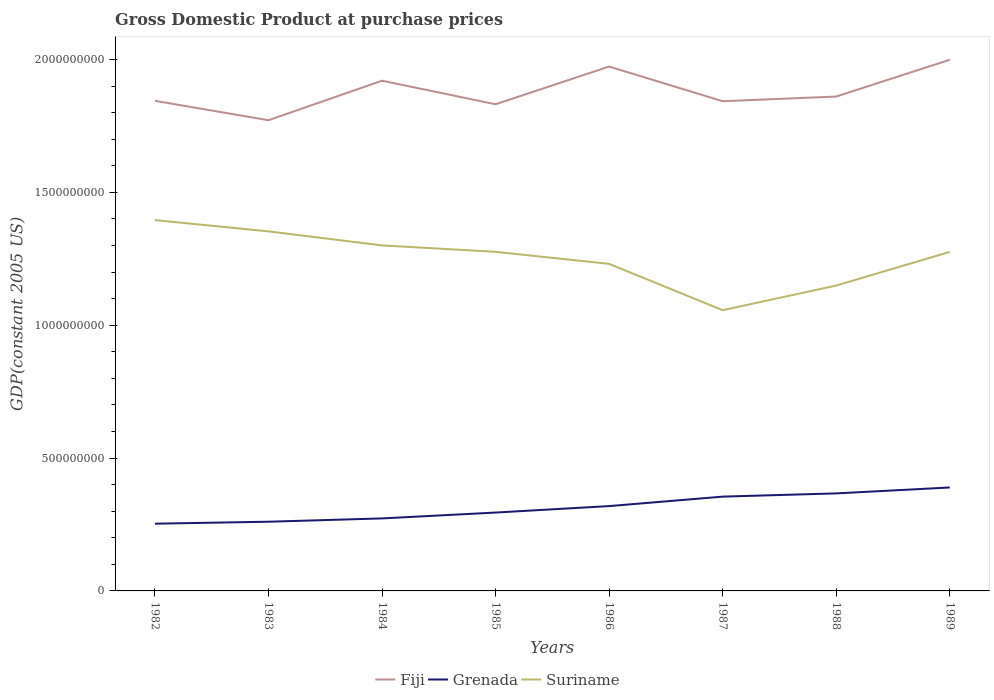How many different coloured lines are there?
Make the answer very short. 3. Does the line corresponding to Suriname intersect with the line corresponding to Fiji?
Make the answer very short. No. Across all years, what is the maximum GDP at purchase prices in Grenada?
Keep it short and to the point. 2.53e+08. What is the total GDP at purchase prices in Grenada in the graph?
Make the answer very short. -9.44e+07. What is the difference between the highest and the second highest GDP at purchase prices in Grenada?
Your answer should be very brief. 1.36e+08. Is the GDP at purchase prices in Suriname strictly greater than the GDP at purchase prices in Grenada over the years?
Your response must be concise. No. How many years are there in the graph?
Your response must be concise. 8. Does the graph contain any zero values?
Provide a short and direct response. No. Does the graph contain grids?
Keep it short and to the point. No. Where does the legend appear in the graph?
Provide a short and direct response. Bottom center. How many legend labels are there?
Your response must be concise. 3. How are the legend labels stacked?
Offer a very short reply. Horizontal. What is the title of the graph?
Your answer should be very brief. Gross Domestic Product at purchase prices. Does "Cameroon" appear as one of the legend labels in the graph?
Provide a succinct answer. No. What is the label or title of the Y-axis?
Make the answer very short. GDP(constant 2005 US). What is the GDP(constant 2005 US) of Fiji in 1982?
Keep it short and to the point. 1.84e+09. What is the GDP(constant 2005 US) of Grenada in 1982?
Your answer should be very brief. 2.53e+08. What is the GDP(constant 2005 US) of Suriname in 1982?
Ensure brevity in your answer.  1.40e+09. What is the GDP(constant 2005 US) in Fiji in 1983?
Keep it short and to the point. 1.77e+09. What is the GDP(constant 2005 US) in Grenada in 1983?
Provide a succinct answer. 2.60e+08. What is the GDP(constant 2005 US) of Suriname in 1983?
Give a very brief answer. 1.35e+09. What is the GDP(constant 2005 US) in Fiji in 1984?
Give a very brief answer. 1.92e+09. What is the GDP(constant 2005 US) in Grenada in 1984?
Your response must be concise. 2.73e+08. What is the GDP(constant 2005 US) in Suriname in 1984?
Your response must be concise. 1.30e+09. What is the GDP(constant 2005 US) of Fiji in 1985?
Offer a terse response. 1.83e+09. What is the GDP(constant 2005 US) of Grenada in 1985?
Ensure brevity in your answer.  2.95e+08. What is the GDP(constant 2005 US) of Suriname in 1985?
Your answer should be very brief. 1.28e+09. What is the GDP(constant 2005 US) of Fiji in 1986?
Offer a terse response. 1.97e+09. What is the GDP(constant 2005 US) of Grenada in 1986?
Offer a terse response. 3.19e+08. What is the GDP(constant 2005 US) of Suriname in 1986?
Your answer should be compact. 1.23e+09. What is the GDP(constant 2005 US) of Fiji in 1987?
Your response must be concise. 1.84e+09. What is the GDP(constant 2005 US) of Grenada in 1987?
Your answer should be very brief. 3.55e+08. What is the GDP(constant 2005 US) in Suriname in 1987?
Make the answer very short. 1.06e+09. What is the GDP(constant 2005 US) of Fiji in 1988?
Give a very brief answer. 1.86e+09. What is the GDP(constant 2005 US) of Grenada in 1988?
Keep it short and to the point. 3.67e+08. What is the GDP(constant 2005 US) in Suriname in 1988?
Make the answer very short. 1.15e+09. What is the GDP(constant 2005 US) in Fiji in 1989?
Your answer should be very brief. 2.00e+09. What is the GDP(constant 2005 US) of Grenada in 1989?
Give a very brief answer. 3.89e+08. What is the GDP(constant 2005 US) in Suriname in 1989?
Your response must be concise. 1.28e+09. Across all years, what is the maximum GDP(constant 2005 US) in Fiji?
Your answer should be very brief. 2.00e+09. Across all years, what is the maximum GDP(constant 2005 US) in Grenada?
Provide a short and direct response. 3.89e+08. Across all years, what is the maximum GDP(constant 2005 US) of Suriname?
Your answer should be very brief. 1.40e+09. Across all years, what is the minimum GDP(constant 2005 US) of Fiji?
Offer a terse response. 1.77e+09. Across all years, what is the minimum GDP(constant 2005 US) in Grenada?
Your answer should be compact. 2.53e+08. Across all years, what is the minimum GDP(constant 2005 US) of Suriname?
Provide a short and direct response. 1.06e+09. What is the total GDP(constant 2005 US) in Fiji in the graph?
Give a very brief answer. 1.50e+1. What is the total GDP(constant 2005 US) of Grenada in the graph?
Keep it short and to the point. 2.51e+09. What is the total GDP(constant 2005 US) of Suriname in the graph?
Your answer should be very brief. 1.00e+1. What is the difference between the GDP(constant 2005 US) in Fiji in 1982 and that in 1983?
Keep it short and to the point. 7.30e+07. What is the difference between the GDP(constant 2005 US) of Grenada in 1982 and that in 1983?
Give a very brief answer. -7.40e+06. What is the difference between the GDP(constant 2005 US) of Suriname in 1982 and that in 1983?
Your answer should be very brief. 4.25e+07. What is the difference between the GDP(constant 2005 US) of Fiji in 1982 and that in 1984?
Give a very brief answer. -7.56e+07. What is the difference between the GDP(constant 2005 US) of Grenada in 1982 and that in 1984?
Your answer should be very brief. -1.99e+07. What is the difference between the GDP(constant 2005 US) of Suriname in 1982 and that in 1984?
Your answer should be very brief. 9.53e+07. What is the difference between the GDP(constant 2005 US) in Fiji in 1982 and that in 1985?
Your response must be concise. 1.29e+07. What is the difference between the GDP(constant 2005 US) in Grenada in 1982 and that in 1985?
Keep it short and to the point. -4.19e+07. What is the difference between the GDP(constant 2005 US) of Suriname in 1982 and that in 1985?
Offer a very short reply. 1.19e+08. What is the difference between the GDP(constant 2005 US) in Fiji in 1982 and that in 1986?
Offer a very short reply. -1.29e+08. What is the difference between the GDP(constant 2005 US) of Grenada in 1982 and that in 1986?
Your answer should be very brief. -6.62e+07. What is the difference between the GDP(constant 2005 US) in Suriname in 1982 and that in 1986?
Provide a succinct answer. 1.65e+08. What is the difference between the GDP(constant 2005 US) in Fiji in 1982 and that in 1987?
Make the answer very short. 1.55e+06. What is the difference between the GDP(constant 2005 US) in Grenada in 1982 and that in 1987?
Offer a very short reply. -1.02e+08. What is the difference between the GDP(constant 2005 US) in Suriname in 1982 and that in 1987?
Provide a succinct answer. 3.39e+08. What is the difference between the GDP(constant 2005 US) of Fiji in 1982 and that in 1988?
Ensure brevity in your answer.  -1.61e+07. What is the difference between the GDP(constant 2005 US) of Grenada in 1982 and that in 1988?
Your answer should be very brief. -1.14e+08. What is the difference between the GDP(constant 2005 US) in Suriname in 1982 and that in 1988?
Provide a succinct answer. 2.46e+08. What is the difference between the GDP(constant 2005 US) of Fiji in 1982 and that in 1989?
Provide a succinct answer. -1.54e+08. What is the difference between the GDP(constant 2005 US) in Grenada in 1982 and that in 1989?
Make the answer very short. -1.36e+08. What is the difference between the GDP(constant 2005 US) in Suriname in 1982 and that in 1989?
Offer a very short reply. 1.20e+08. What is the difference between the GDP(constant 2005 US) in Fiji in 1983 and that in 1984?
Your response must be concise. -1.49e+08. What is the difference between the GDP(constant 2005 US) of Grenada in 1983 and that in 1984?
Your response must be concise. -1.25e+07. What is the difference between the GDP(constant 2005 US) in Suriname in 1983 and that in 1984?
Provide a short and direct response. 5.28e+07. What is the difference between the GDP(constant 2005 US) of Fiji in 1983 and that in 1985?
Your answer should be very brief. -6.01e+07. What is the difference between the GDP(constant 2005 US) in Grenada in 1983 and that in 1985?
Keep it short and to the point. -3.45e+07. What is the difference between the GDP(constant 2005 US) of Suriname in 1983 and that in 1985?
Your response must be concise. 7.70e+07. What is the difference between the GDP(constant 2005 US) in Fiji in 1983 and that in 1986?
Provide a succinct answer. -2.02e+08. What is the difference between the GDP(constant 2005 US) of Grenada in 1983 and that in 1986?
Offer a very short reply. -5.88e+07. What is the difference between the GDP(constant 2005 US) of Suriname in 1983 and that in 1986?
Ensure brevity in your answer.  1.22e+08. What is the difference between the GDP(constant 2005 US) in Fiji in 1983 and that in 1987?
Offer a terse response. -7.15e+07. What is the difference between the GDP(constant 2005 US) in Grenada in 1983 and that in 1987?
Provide a short and direct response. -9.44e+07. What is the difference between the GDP(constant 2005 US) of Suriname in 1983 and that in 1987?
Give a very brief answer. 2.97e+08. What is the difference between the GDP(constant 2005 US) in Fiji in 1983 and that in 1988?
Your answer should be compact. -8.91e+07. What is the difference between the GDP(constant 2005 US) in Grenada in 1983 and that in 1988?
Your answer should be compact. -1.07e+08. What is the difference between the GDP(constant 2005 US) of Suriname in 1983 and that in 1988?
Ensure brevity in your answer.  2.04e+08. What is the difference between the GDP(constant 2005 US) of Fiji in 1983 and that in 1989?
Your answer should be compact. -2.27e+08. What is the difference between the GDP(constant 2005 US) in Grenada in 1983 and that in 1989?
Give a very brief answer. -1.29e+08. What is the difference between the GDP(constant 2005 US) in Suriname in 1983 and that in 1989?
Make the answer very short. 7.72e+07. What is the difference between the GDP(constant 2005 US) of Fiji in 1984 and that in 1985?
Your answer should be compact. 8.86e+07. What is the difference between the GDP(constant 2005 US) of Grenada in 1984 and that in 1985?
Offer a terse response. -2.20e+07. What is the difference between the GDP(constant 2005 US) of Suriname in 1984 and that in 1985?
Your answer should be very brief. 2.42e+07. What is the difference between the GDP(constant 2005 US) of Fiji in 1984 and that in 1986?
Your response must be concise. -5.34e+07. What is the difference between the GDP(constant 2005 US) in Grenada in 1984 and that in 1986?
Your answer should be very brief. -4.64e+07. What is the difference between the GDP(constant 2005 US) in Suriname in 1984 and that in 1986?
Provide a succinct answer. 6.94e+07. What is the difference between the GDP(constant 2005 US) in Fiji in 1984 and that in 1987?
Ensure brevity in your answer.  7.72e+07. What is the difference between the GDP(constant 2005 US) in Grenada in 1984 and that in 1987?
Offer a terse response. -8.20e+07. What is the difference between the GDP(constant 2005 US) of Suriname in 1984 and that in 1987?
Your answer should be compact. 2.44e+08. What is the difference between the GDP(constant 2005 US) of Fiji in 1984 and that in 1988?
Your answer should be compact. 5.96e+07. What is the difference between the GDP(constant 2005 US) in Grenada in 1984 and that in 1988?
Provide a succinct answer. -9.41e+07. What is the difference between the GDP(constant 2005 US) in Suriname in 1984 and that in 1988?
Keep it short and to the point. 1.51e+08. What is the difference between the GDP(constant 2005 US) of Fiji in 1984 and that in 1989?
Give a very brief answer. -7.88e+07. What is the difference between the GDP(constant 2005 US) in Grenada in 1984 and that in 1989?
Ensure brevity in your answer.  -1.16e+08. What is the difference between the GDP(constant 2005 US) in Suriname in 1984 and that in 1989?
Ensure brevity in your answer.  2.44e+07. What is the difference between the GDP(constant 2005 US) in Fiji in 1985 and that in 1986?
Your answer should be very brief. -1.42e+08. What is the difference between the GDP(constant 2005 US) in Grenada in 1985 and that in 1986?
Keep it short and to the point. -2.43e+07. What is the difference between the GDP(constant 2005 US) of Suriname in 1985 and that in 1986?
Offer a very short reply. 4.52e+07. What is the difference between the GDP(constant 2005 US) of Fiji in 1985 and that in 1987?
Keep it short and to the point. -1.14e+07. What is the difference between the GDP(constant 2005 US) in Grenada in 1985 and that in 1987?
Offer a terse response. -5.99e+07. What is the difference between the GDP(constant 2005 US) in Suriname in 1985 and that in 1987?
Your answer should be compact. 2.20e+08. What is the difference between the GDP(constant 2005 US) in Fiji in 1985 and that in 1988?
Make the answer very short. -2.90e+07. What is the difference between the GDP(constant 2005 US) in Grenada in 1985 and that in 1988?
Provide a short and direct response. -7.21e+07. What is the difference between the GDP(constant 2005 US) in Suriname in 1985 and that in 1988?
Your response must be concise. 1.27e+08. What is the difference between the GDP(constant 2005 US) in Fiji in 1985 and that in 1989?
Ensure brevity in your answer.  -1.67e+08. What is the difference between the GDP(constant 2005 US) of Grenada in 1985 and that in 1989?
Provide a succinct answer. -9.44e+07. What is the difference between the GDP(constant 2005 US) of Suriname in 1985 and that in 1989?
Ensure brevity in your answer.  2.67e+05. What is the difference between the GDP(constant 2005 US) in Fiji in 1986 and that in 1987?
Offer a terse response. 1.31e+08. What is the difference between the GDP(constant 2005 US) in Grenada in 1986 and that in 1987?
Your answer should be compact. -3.56e+07. What is the difference between the GDP(constant 2005 US) of Suriname in 1986 and that in 1987?
Offer a very short reply. 1.74e+08. What is the difference between the GDP(constant 2005 US) of Fiji in 1986 and that in 1988?
Your answer should be very brief. 1.13e+08. What is the difference between the GDP(constant 2005 US) in Grenada in 1986 and that in 1988?
Your answer should be compact. -4.78e+07. What is the difference between the GDP(constant 2005 US) in Suriname in 1986 and that in 1988?
Make the answer very short. 8.16e+07. What is the difference between the GDP(constant 2005 US) of Fiji in 1986 and that in 1989?
Offer a terse response. -2.55e+07. What is the difference between the GDP(constant 2005 US) in Grenada in 1986 and that in 1989?
Give a very brief answer. -7.00e+07. What is the difference between the GDP(constant 2005 US) of Suriname in 1986 and that in 1989?
Your answer should be very brief. -4.50e+07. What is the difference between the GDP(constant 2005 US) in Fiji in 1987 and that in 1988?
Make the answer very short. -1.76e+07. What is the difference between the GDP(constant 2005 US) in Grenada in 1987 and that in 1988?
Offer a terse response. -1.22e+07. What is the difference between the GDP(constant 2005 US) in Suriname in 1987 and that in 1988?
Your answer should be very brief. -9.27e+07. What is the difference between the GDP(constant 2005 US) of Fiji in 1987 and that in 1989?
Offer a very short reply. -1.56e+08. What is the difference between the GDP(constant 2005 US) of Grenada in 1987 and that in 1989?
Your answer should be very brief. -3.44e+07. What is the difference between the GDP(constant 2005 US) in Suriname in 1987 and that in 1989?
Give a very brief answer. -2.19e+08. What is the difference between the GDP(constant 2005 US) of Fiji in 1988 and that in 1989?
Ensure brevity in your answer.  -1.38e+08. What is the difference between the GDP(constant 2005 US) of Grenada in 1988 and that in 1989?
Provide a short and direct response. -2.23e+07. What is the difference between the GDP(constant 2005 US) in Suriname in 1988 and that in 1989?
Make the answer very short. -1.27e+08. What is the difference between the GDP(constant 2005 US) of Fiji in 1982 and the GDP(constant 2005 US) of Grenada in 1983?
Offer a terse response. 1.58e+09. What is the difference between the GDP(constant 2005 US) in Fiji in 1982 and the GDP(constant 2005 US) in Suriname in 1983?
Your answer should be very brief. 4.91e+08. What is the difference between the GDP(constant 2005 US) in Grenada in 1982 and the GDP(constant 2005 US) in Suriname in 1983?
Ensure brevity in your answer.  -1.10e+09. What is the difference between the GDP(constant 2005 US) of Fiji in 1982 and the GDP(constant 2005 US) of Grenada in 1984?
Offer a terse response. 1.57e+09. What is the difference between the GDP(constant 2005 US) of Fiji in 1982 and the GDP(constant 2005 US) of Suriname in 1984?
Your answer should be very brief. 5.44e+08. What is the difference between the GDP(constant 2005 US) of Grenada in 1982 and the GDP(constant 2005 US) of Suriname in 1984?
Offer a very short reply. -1.05e+09. What is the difference between the GDP(constant 2005 US) of Fiji in 1982 and the GDP(constant 2005 US) of Grenada in 1985?
Offer a very short reply. 1.55e+09. What is the difference between the GDP(constant 2005 US) in Fiji in 1982 and the GDP(constant 2005 US) in Suriname in 1985?
Offer a terse response. 5.68e+08. What is the difference between the GDP(constant 2005 US) in Grenada in 1982 and the GDP(constant 2005 US) in Suriname in 1985?
Your answer should be very brief. -1.02e+09. What is the difference between the GDP(constant 2005 US) in Fiji in 1982 and the GDP(constant 2005 US) in Grenada in 1986?
Your answer should be very brief. 1.53e+09. What is the difference between the GDP(constant 2005 US) of Fiji in 1982 and the GDP(constant 2005 US) of Suriname in 1986?
Provide a succinct answer. 6.14e+08. What is the difference between the GDP(constant 2005 US) of Grenada in 1982 and the GDP(constant 2005 US) of Suriname in 1986?
Offer a very short reply. -9.78e+08. What is the difference between the GDP(constant 2005 US) in Fiji in 1982 and the GDP(constant 2005 US) in Grenada in 1987?
Your answer should be compact. 1.49e+09. What is the difference between the GDP(constant 2005 US) in Fiji in 1982 and the GDP(constant 2005 US) in Suriname in 1987?
Offer a terse response. 7.88e+08. What is the difference between the GDP(constant 2005 US) of Grenada in 1982 and the GDP(constant 2005 US) of Suriname in 1987?
Provide a short and direct response. -8.03e+08. What is the difference between the GDP(constant 2005 US) of Fiji in 1982 and the GDP(constant 2005 US) of Grenada in 1988?
Your answer should be compact. 1.48e+09. What is the difference between the GDP(constant 2005 US) in Fiji in 1982 and the GDP(constant 2005 US) in Suriname in 1988?
Ensure brevity in your answer.  6.95e+08. What is the difference between the GDP(constant 2005 US) in Grenada in 1982 and the GDP(constant 2005 US) in Suriname in 1988?
Offer a terse response. -8.96e+08. What is the difference between the GDP(constant 2005 US) of Fiji in 1982 and the GDP(constant 2005 US) of Grenada in 1989?
Keep it short and to the point. 1.46e+09. What is the difference between the GDP(constant 2005 US) in Fiji in 1982 and the GDP(constant 2005 US) in Suriname in 1989?
Your response must be concise. 5.69e+08. What is the difference between the GDP(constant 2005 US) in Grenada in 1982 and the GDP(constant 2005 US) in Suriname in 1989?
Give a very brief answer. -1.02e+09. What is the difference between the GDP(constant 2005 US) in Fiji in 1983 and the GDP(constant 2005 US) in Grenada in 1984?
Ensure brevity in your answer.  1.50e+09. What is the difference between the GDP(constant 2005 US) in Fiji in 1983 and the GDP(constant 2005 US) in Suriname in 1984?
Give a very brief answer. 4.71e+08. What is the difference between the GDP(constant 2005 US) in Grenada in 1983 and the GDP(constant 2005 US) in Suriname in 1984?
Provide a succinct answer. -1.04e+09. What is the difference between the GDP(constant 2005 US) of Fiji in 1983 and the GDP(constant 2005 US) of Grenada in 1985?
Give a very brief answer. 1.48e+09. What is the difference between the GDP(constant 2005 US) of Fiji in 1983 and the GDP(constant 2005 US) of Suriname in 1985?
Make the answer very short. 4.95e+08. What is the difference between the GDP(constant 2005 US) of Grenada in 1983 and the GDP(constant 2005 US) of Suriname in 1985?
Your answer should be very brief. -1.02e+09. What is the difference between the GDP(constant 2005 US) in Fiji in 1983 and the GDP(constant 2005 US) in Grenada in 1986?
Your answer should be very brief. 1.45e+09. What is the difference between the GDP(constant 2005 US) of Fiji in 1983 and the GDP(constant 2005 US) of Suriname in 1986?
Offer a very short reply. 5.40e+08. What is the difference between the GDP(constant 2005 US) of Grenada in 1983 and the GDP(constant 2005 US) of Suriname in 1986?
Offer a very short reply. -9.70e+08. What is the difference between the GDP(constant 2005 US) of Fiji in 1983 and the GDP(constant 2005 US) of Grenada in 1987?
Offer a very short reply. 1.42e+09. What is the difference between the GDP(constant 2005 US) of Fiji in 1983 and the GDP(constant 2005 US) of Suriname in 1987?
Ensure brevity in your answer.  7.15e+08. What is the difference between the GDP(constant 2005 US) of Grenada in 1983 and the GDP(constant 2005 US) of Suriname in 1987?
Offer a terse response. -7.96e+08. What is the difference between the GDP(constant 2005 US) in Fiji in 1983 and the GDP(constant 2005 US) in Grenada in 1988?
Provide a succinct answer. 1.40e+09. What is the difference between the GDP(constant 2005 US) in Fiji in 1983 and the GDP(constant 2005 US) in Suriname in 1988?
Provide a succinct answer. 6.22e+08. What is the difference between the GDP(constant 2005 US) of Grenada in 1983 and the GDP(constant 2005 US) of Suriname in 1988?
Your response must be concise. -8.89e+08. What is the difference between the GDP(constant 2005 US) of Fiji in 1983 and the GDP(constant 2005 US) of Grenada in 1989?
Give a very brief answer. 1.38e+09. What is the difference between the GDP(constant 2005 US) of Fiji in 1983 and the GDP(constant 2005 US) of Suriname in 1989?
Give a very brief answer. 4.96e+08. What is the difference between the GDP(constant 2005 US) in Grenada in 1983 and the GDP(constant 2005 US) in Suriname in 1989?
Give a very brief answer. -1.02e+09. What is the difference between the GDP(constant 2005 US) in Fiji in 1984 and the GDP(constant 2005 US) in Grenada in 1985?
Provide a short and direct response. 1.62e+09. What is the difference between the GDP(constant 2005 US) in Fiji in 1984 and the GDP(constant 2005 US) in Suriname in 1985?
Provide a succinct answer. 6.44e+08. What is the difference between the GDP(constant 2005 US) in Grenada in 1984 and the GDP(constant 2005 US) in Suriname in 1985?
Provide a short and direct response. -1.00e+09. What is the difference between the GDP(constant 2005 US) of Fiji in 1984 and the GDP(constant 2005 US) of Grenada in 1986?
Provide a short and direct response. 1.60e+09. What is the difference between the GDP(constant 2005 US) in Fiji in 1984 and the GDP(constant 2005 US) in Suriname in 1986?
Offer a very short reply. 6.89e+08. What is the difference between the GDP(constant 2005 US) of Grenada in 1984 and the GDP(constant 2005 US) of Suriname in 1986?
Make the answer very short. -9.58e+08. What is the difference between the GDP(constant 2005 US) of Fiji in 1984 and the GDP(constant 2005 US) of Grenada in 1987?
Offer a very short reply. 1.57e+09. What is the difference between the GDP(constant 2005 US) in Fiji in 1984 and the GDP(constant 2005 US) in Suriname in 1987?
Keep it short and to the point. 8.63e+08. What is the difference between the GDP(constant 2005 US) of Grenada in 1984 and the GDP(constant 2005 US) of Suriname in 1987?
Make the answer very short. -7.84e+08. What is the difference between the GDP(constant 2005 US) of Fiji in 1984 and the GDP(constant 2005 US) of Grenada in 1988?
Offer a very short reply. 1.55e+09. What is the difference between the GDP(constant 2005 US) in Fiji in 1984 and the GDP(constant 2005 US) in Suriname in 1988?
Ensure brevity in your answer.  7.71e+08. What is the difference between the GDP(constant 2005 US) in Grenada in 1984 and the GDP(constant 2005 US) in Suriname in 1988?
Your answer should be very brief. -8.76e+08. What is the difference between the GDP(constant 2005 US) of Fiji in 1984 and the GDP(constant 2005 US) of Grenada in 1989?
Your answer should be compact. 1.53e+09. What is the difference between the GDP(constant 2005 US) in Fiji in 1984 and the GDP(constant 2005 US) in Suriname in 1989?
Make the answer very short. 6.44e+08. What is the difference between the GDP(constant 2005 US) of Grenada in 1984 and the GDP(constant 2005 US) of Suriname in 1989?
Your answer should be very brief. -1.00e+09. What is the difference between the GDP(constant 2005 US) of Fiji in 1985 and the GDP(constant 2005 US) of Grenada in 1986?
Keep it short and to the point. 1.51e+09. What is the difference between the GDP(constant 2005 US) in Fiji in 1985 and the GDP(constant 2005 US) in Suriname in 1986?
Offer a terse response. 6.01e+08. What is the difference between the GDP(constant 2005 US) in Grenada in 1985 and the GDP(constant 2005 US) in Suriname in 1986?
Provide a short and direct response. -9.36e+08. What is the difference between the GDP(constant 2005 US) of Fiji in 1985 and the GDP(constant 2005 US) of Grenada in 1987?
Give a very brief answer. 1.48e+09. What is the difference between the GDP(constant 2005 US) in Fiji in 1985 and the GDP(constant 2005 US) in Suriname in 1987?
Offer a very short reply. 7.75e+08. What is the difference between the GDP(constant 2005 US) of Grenada in 1985 and the GDP(constant 2005 US) of Suriname in 1987?
Offer a terse response. -7.62e+08. What is the difference between the GDP(constant 2005 US) in Fiji in 1985 and the GDP(constant 2005 US) in Grenada in 1988?
Offer a terse response. 1.46e+09. What is the difference between the GDP(constant 2005 US) of Fiji in 1985 and the GDP(constant 2005 US) of Suriname in 1988?
Your answer should be very brief. 6.82e+08. What is the difference between the GDP(constant 2005 US) in Grenada in 1985 and the GDP(constant 2005 US) in Suriname in 1988?
Offer a very short reply. -8.54e+08. What is the difference between the GDP(constant 2005 US) of Fiji in 1985 and the GDP(constant 2005 US) of Grenada in 1989?
Your answer should be compact. 1.44e+09. What is the difference between the GDP(constant 2005 US) in Fiji in 1985 and the GDP(constant 2005 US) in Suriname in 1989?
Keep it short and to the point. 5.56e+08. What is the difference between the GDP(constant 2005 US) in Grenada in 1985 and the GDP(constant 2005 US) in Suriname in 1989?
Your answer should be very brief. -9.81e+08. What is the difference between the GDP(constant 2005 US) of Fiji in 1986 and the GDP(constant 2005 US) of Grenada in 1987?
Your answer should be very brief. 1.62e+09. What is the difference between the GDP(constant 2005 US) of Fiji in 1986 and the GDP(constant 2005 US) of Suriname in 1987?
Offer a very short reply. 9.17e+08. What is the difference between the GDP(constant 2005 US) in Grenada in 1986 and the GDP(constant 2005 US) in Suriname in 1987?
Your answer should be compact. -7.37e+08. What is the difference between the GDP(constant 2005 US) in Fiji in 1986 and the GDP(constant 2005 US) in Grenada in 1988?
Give a very brief answer. 1.61e+09. What is the difference between the GDP(constant 2005 US) in Fiji in 1986 and the GDP(constant 2005 US) in Suriname in 1988?
Offer a very short reply. 8.24e+08. What is the difference between the GDP(constant 2005 US) of Grenada in 1986 and the GDP(constant 2005 US) of Suriname in 1988?
Provide a succinct answer. -8.30e+08. What is the difference between the GDP(constant 2005 US) of Fiji in 1986 and the GDP(constant 2005 US) of Grenada in 1989?
Provide a short and direct response. 1.58e+09. What is the difference between the GDP(constant 2005 US) of Fiji in 1986 and the GDP(constant 2005 US) of Suriname in 1989?
Offer a very short reply. 6.98e+08. What is the difference between the GDP(constant 2005 US) of Grenada in 1986 and the GDP(constant 2005 US) of Suriname in 1989?
Keep it short and to the point. -9.57e+08. What is the difference between the GDP(constant 2005 US) of Fiji in 1987 and the GDP(constant 2005 US) of Grenada in 1988?
Ensure brevity in your answer.  1.48e+09. What is the difference between the GDP(constant 2005 US) in Fiji in 1987 and the GDP(constant 2005 US) in Suriname in 1988?
Provide a succinct answer. 6.94e+08. What is the difference between the GDP(constant 2005 US) of Grenada in 1987 and the GDP(constant 2005 US) of Suriname in 1988?
Give a very brief answer. -7.94e+08. What is the difference between the GDP(constant 2005 US) in Fiji in 1987 and the GDP(constant 2005 US) in Grenada in 1989?
Your answer should be compact. 1.45e+09. What is the difference between the GDP(constant 2005 US) of Fiji in 1987 and the GDP(constant 2005 US) of Suriname in 1989?
Your answer should be compact. 5.67e+08. What is the difference between the GDP(constant 2005 US) of Grenada in 1987 and the GDP(constant 2005 US) of Suriname in 1989?
Your answer should be very brief. -9.21e+08. What is the difference between the GDP(constant 2005 US) of Fiji in 1988 and the GDP(constant 2005 US) of Grenada in 1989?
Provide a succinct answer. 1.47e+09. What is the difference between the GDP(constant 2005 US) in Fiji in 1988 and the GDP(constant 2005 US) in Suriname in 1989?
Offer a very short reply. 5.85e+08. What is the difference between the GDP(constant 2005 US) in Grenada in 1988 and the GDP(constant 2005 US) in Suriname in 1989?
Offer a very short reply. -9.09e+08. What is the average GDP(constant 2005 US) in Fiji per year?
Ensure brevity in your answer.  1.88e+09. What is the average GDP(constant 2005 US) in Grenada per year?
Provide a short and direct response. 3.14e+08. What is the average GDP(constant 2005 US) of Suriname per year?
Your answer should be very brief. 1.25e+09. In the year 1982, what is the difference between the GDP(constant 2005 US) of Fiji and GDP(constant 2005 US) of Grenada?
Your response must be concise. 1.59e+09. In the year 1982, what is the difference between the GDP(constant 2005 US) of Fiji and GDP(constant 2005 US) of Suriname?
Provide a succinct answer. 4.49e+08. In the year 1982, what is the difference between the GDP(constant 2005 US) of Grenada and GDP(constant 2005 US) of Suriname?
Keep it short and to the point. -1.14e+09. In the year 1983, what is the difference between the GDP(constant 2005 US) of Fiji and GDP(constant 2005 US) of Grenada?
Give a very brief answer. 1.51e+09. In the year 1983, what is the difference between the GDP(constant 2005 US) of Fiji and GDP(constant 2005 US) of Suriname?
Your answer should be compact. 4.18e+08. In the year 1983, what is the difference between the GDP(constant 2005 US) of Grenada and GDP(constant 2005 US) of Suriname?
Make the answer very short. -1.09e+09. In the year 1984, what is the difference between the GDP(constant 2005 US) in Fiji and GDP(constant 2005 US) in Grenada?
Your answer should be very brief. 1.65e+09. In the year 1984, what is the difference between the GDP(constant 2005 US) in Fiji and GDP(constant 2005 US) in Suriname?
Ensure brevity in your answer.  6.20e+08. In the year 1984, what is the difference between the GDP(constant 2005 US) in Grenada and GDP(constant 2005 US) in Suriname?
Your answer should be compact. -1.03e+09. In the year 1985, what is the difference between the GDP(constant 2005 US) in Fiji and GDP(constant 2005 US) in Grenada?
Provide a short and direct response. 1.54e+09. In the year 1985, what is the difference between the GDP(constant 2005 US) in Fiji and GDP(constant 2005 US) in Suriname?
Keep it short and to the point. 5.55e+08. In the year 1985, what is the difference between the GDP(constant 2005 US) in Grenada and GDP(constant 2005 US) in Suriname?
Your answer should be compact. -9.81e+08. In the year 1986, what is the difference between the GDP(constant 2005 US) in Fiji and GDP(constant 2005 US) in Grenada?
Give a very brief answer. 1.65e+09. In the year 1986, what is the difference between the GDP(constant 2005 US) of Fiji and GDP(constant 2005 US) of Suriname?
Provide a short and direct response. 7.42e+08. In the year 1986, what is the difference between the GDP(constant 2005 US) of Grenada and GDP(constant 2005 US) of Suriname?
Give a very brief answer. -9.12e+08. In the year 1987, what is the difference between the GDP(constant 2005 US) in Fiji and GDP(constant 2005 US) in Grenada?
Ensure brevity in your answer.  1.49e+09. In the year 1987, what is the difference between the GDP(constant 2005 US) of Fiji and GDP(constant 2005 US) of Suriname?
Your answer should be very brief. 7.86e+08. In the year 1987, what is the difference between the GDP(constant 2005 US) in Grenada and GDP(constant 2005 US) in Suriname?
Make the answer very short. -7.02e+08. In the year 1988, what is the difference between the GDP(constant 2005 US) in Fiji and GDP(constant 2005 US) in Grenada?
Make the answer very short. 1.49e+09. In the year 1988, what is the difference between the GDP(constant 2005 US) in Fiji and GDP(constant 2005 US) in Suriname?
Keep it short and to the point. 7.11e+08. In the year 1988, what is the difference between the GDP(constant 2005 US) of Grenada and GDP(constant 2005 US) of Suriname?
Your response must be concise. -7.82e+08. In the year 1989, what is the difference between the GDP(constant 2005 US) of Fiji and GDP(constant 2005 US) of Grenada?
Your answer should be very brief. 1.61e+09. In the year 1989, what is the difference between the GDP(constant 2005 US) of Fiji and GDP(constant 2005 US) of Suriname?
Make the answer very short. 7.23e+08. In the year 1989, what is the difference between the GDP(constant 2005 US) of Grenada and GDP(constant 2005 US) of Suriname?
Ensure brevity in your answer.  -8.86e+08. What is the ratio of the GDP(constant 2005 US) in Fiji in 1982 to that in 1983?
Your response must be concise. 1.04. What is the ratio of the GDP(constant 2005 US) in Grenada in 1982 to that in 1983?
Provide a succinct answer. 0.97. What is the ratio of the GDP(constant 2005 US) of Suriname in 1982 to that in 1983?
Ensure brevity in your answer.  1.03. What is the ratio of the GDP(constant 2005 US) in Fiji in 1982 to that in 1984?
Ensure brevity in your answer.  0.96. What is the ratio of the GDP(constant 2005 US) in Grenada in 1982 to that in 1984?
Provide a short and direct response. 0.93. What is the ratio of the GDP(constant 2005 US) in Suriname in 1982 to that in 1984?
Keep it short and to the point. 1.07. What is the ratio of the GDP(constant 2005 US) of Fiji in 1982 to that in 1985?
Provide a succinct answer. 1.01. What is the ratio of the GDP(constant 2005 US) in Grenada in 1982 to that in 1985?
Keep it short and to the point. 0.86. What is the ratio of the GDP(constant 2005 US) in Suriname in 1982 to that in 1985?
Offer a terse response. 1.09. What is the ratio of the GDP(constant 2005 US) in Fiji in 1982 to that in 1986?
Your answer should be very brief. 0.93. What is the ratio of the GDP(constant 2005 US) of Grenada in 1982 to that in 1986?
Provide a short and direct response. 0.79. What is the ratio of the GDP(constant 2005 US) in Suriname in 1982 to that in 1986?
Your answer should be compact. 1.13. What is the ratio of the GDP(constant 2005 US) of Grenada in 1982 to that in 1987?
Ensure brevity in your answer.  0.71. What is the ratio of the GDP(constant 2005 US) of Suriname in 1982 to that in 1987?
Provide a succinct answer. 1.32. What is the ratio of the GDP(constant 2005 US) of Fiji in 1982 to that in 1988?
Provide a succinct answer. 0.99. What is the ratio of the GDP(constant 2005 US) of Grenada in 1982 to that in 1988?
Offer a very short reply. 0.69. What is the ratio of the GDP(constant 2005 US) of Suriname in 1982 to that in 1988?
Your answer should be very brief. 1.21. What is the ratio of the GDP(constant 2005 US) of Fiji in 1982 to that in 1989?
Your answer should be very brief. 0.92. What is the ratio of the GDP(constant 2005 US) of Grenada in 1982 to that in 1989?
Give a very brief answer. 0.65. What is the ratio of the GDP(constant 2005 US) in Suriname in 1982 to that in 1989?
Offer a very short reply. 1.09. What is the ratio of the GDP(constant 2005 US) in Fiji in 1983 to that in 1984?
Provide a succinct answer. 0.92. What is the ratio of the GDP(constant 2005 US) of Grenada in 1983 to that in 1984?
Your answer should be compact. 0.95. What is the ratio of the GDP(constant 2005 US) in Suriname in 1983 to that in 1984?
Provide a short and direct response. 1.04. What is the ratio of the GDP(constant 2005 US) of Fiji in 1983 to that in 1985?
Your answer should be compact. 0.97. What is the ratio of the GDP(constant 2005 US) of Grenada in 1983 to that in 1985?
Your answer should be compact. 0.88. What is the ratio of the GDP(constant 2005 US) in Suriname in 1983 to that in 1985?
Give a very brief answer. 1.06. What is the ratio of the GDP(constant 2005 US) in Fiji in 1983 to that in 1986?
Offer a very short reply. 0.9. What is the ratio of the GDP(constant 2005 US) in Grenada in 1983 to that in 1986?
Your response must be concise. 0.82. What is the ratio of the GDP(constant 2005 US) of Suriname in 1983 to that in 1986?
Your answer should be compact. 1.1. What is the ratio of the GDP(constant 2005 US) of Fiji in 1983 to that in 1987?
Provide a short and direct response. 0.96. What is the ratio of the GDP(constant 2005 US) of Grenada in 1983 to that in 1987?
Your response must be concise. 0.73. What is the ratio of the GDP(constant 2005 US) of Suriname in 1983 to that in 1987?
Give a very brief answer. 1.28. What is the ratio of the GDP(constant 2005 US) in Fiji in 1983 to that in 1988?
Keep it short and to the point. 0.95. What is the ratio of the GDP(constant 2005 US) of Grenada in 1983 to that in 1988?
Your response must be concise. 0.71. What is the ratio of the GDP(constant 2005 US) in Suriname in 1983 to that in 1988?
Your response must be concise. 1.18. What is the ratio of the GDP(constant 2005 US) in Fiji in 1983 to that in 1989?
Make the answer very short. 0.89. What is the ratio of the GDP(constant 2005 US) in Grenada in 1983 to that in 1989?
Your answer should be compact. 0.67. What is the ratio of the GDP(constant 2005 US) of Suriname in 1983 to that in 1989?
Provide a succinct answer. 1.06. What is the ratio of the GDP(constant 2005 US) in Fiji in 1984 to that in 1985?
Keep it short and to the point. 1.05. What is the ratio of the GDP(constant 2005 US) of Grenada in 1984 to that in 1985?
Provide a succinct answer. 0.93. What is the ratio of the GDP(constant 2005 US) in Suriname in 1984 to that in 1985?
Provide a short and direct response. 1.02. What is the ratio of the GDP(constant 2005 US) of Grenada in 1984 to that in 1986?
Give a very brief answer. 0.85. What is the ratio of the GDP(constant 2005 US) in Suriname in 1984 to that in 1986?
Offer a terse response. 1.06. What is the ratio of the GDP(constant 2005 US) of Fiji in 1984 to that in 1987?
Provide a short and direct response. 1.04. What is the ratio of the GDP(constant 2005 US) of Grenada in 1984 to that in 1987?
Your answer should be very brief. 0.77. What is the ratio of the GDP(constant 2005 US) in Suriname in 1984 to that in 1987?
Provide a short and direct response. 1.23. What is the ratio of the GDP(constant 2005 US) of Fiji in 1984 to that in 1988?
Give a very brief answer. 1.03. What is the ratio of the GDP(constant 2005 US) in Grenada in 1984 to that in 1988?
Provide a short and direct response. 0.74. What is the ratio of the GDP(constant 2005 US) of Suriname in 1984 to that in 1988?
Make the answer very short. 1.13. What is the ratio of the GDP(constant 2005 US) of Fiji in 1984 to that in 1989?
Provide a short and direct response. 0.96. What is the ratio of the GDP(constant 2005 US) in Grenada in 1984 to that in 1989?
Your answer should be compact. 0.7. What is the ratio of the GDP(constant 2005 US) in Suriname in 1984 to that in 1989?
Offer a very short reply. 1.02. What is the ratio of the GDP(constant 2005 US) in Fiji in 1985 to that in 1986?
Offer a terse response. 0.93. What is the ratio of the GDP(constant 2005 US) of Grenada in 1985 to that in 1986?
Ensure brevity in your answer.  0.92. What is the ratio of the GDP(constant 2005 US) in Suriname in 1985 to that in 1986?
Give a very brief answer. 1.04. What is the ratio of the GDP(constant 2005 US) in Fiji in 1985 to that in 1987?
Give a very brief answer. 0.99. What is the ratio of the GDP(constant 2005 US) in Grenada in 1985 to that in 1987?
Provide a short and direct response. 0.83. What is the ratio of the GDP(constant 2005 US) of Suriname in 1985 to that in 1987?
Your response must be concise. 1.21. What is the ratio of the GDP(constant 2005 US) of Fiji in 1985 to that in 1988?
Make the answer very short. 0.98. What is the ratio of the GDP(constant 2005 US) in Grenada in 1985 to that in 1988?
Provide a succinct answer. 0.8. What is the ratio of the GDP(constant 2005 US) in Suriname in 1985 to that in 1988?
Your answer should be very brief. 1.11. What is the ratio of the GDP(constant 2005 US) in Fiji in 1985 to that in 1989?
Provide a succinct answer. 0.92. What is the ratio of the GDP(constant 2005 US) in Grenada in 1985 to that in 1989?
Offer a terse response. 0.76. What is the ratio of the GDP(constant 2005 US) of Suriname in 1985 to that in 1989?
Offer a very short reply. 1. What is the ratio of the GDP(constant 2005 US) in Fiji in 1986 to that in 1987?
Give a very brief answer. 1.07. What is the ratio of the GDP(constant 2005 US) in Grenada in 1986 to that in 1987?
Provide a succinct answer. 0.9. What is the ratio of the GDP(constant 2005 US) in Suriname in 1986 to that in 1987?
Make the answer very short. 1.17. What is the ratio of the GDP(constant 2005 US) of Fiji in 1986 to that in 1988?
Give a very brief answer. 1.06. What is the ratio of the GDP(constant 2005 US) in Grenada in 1986 to that in 1988?
Ensure brevity in your answer.  0.87. What is the ratio of the GDP(constant 2005 US) in Suriname in 1986 to that in 1988?
Keep it short and to the point. 1.07. What is the ratio of the GDP(constant 2005 US) in Fiji in 1986 to that in 1989?
Provide a short and direct response. 0.99. What is the ratio of the GDP(constant 2005 US) in Grenada in 1986 to that in 1989?
Your answer should be very brief. 0.82. What is the ratio of the GDP(constant 2005 US) in Suriname in 1986 to that in 1989?
Your response must be concise. 0.96. What is the ratio of the GDP(constant 2005 US) in Grenada in 1987 to that in 1988?
Ensure brevity in your answer.  0.97. What is the ratio of the GDP(constant 2005 US) of Suriname in 1987 to that in 1988?
Ensure brevity in your answer.  0.92. What is the ratio of the GDP(constant 2005 US) of Fiji in 1987 to that in 1989?
Give a very brief answer. 0.92. What is the ratio of the GDP(constant 2005 US) of Grenada in 1987 to that in 1989?
Your answer should be compact. 0.91. What is the ratio of the GDP(constant 2005 US) in Suriname in 1987 to that in 1989?
Your answer should be very brief. 0.83. What is the ratio of the GDP(constant 2005 US) in Fiji in 1988 to that in 1989?
Give a very brief answer. 0.93. What is the ratio of the GDP(constant 2005 US) of Grenada in 1988 to that in 1989?
Your response must be concise. 0.94. What is the ratio of the GDP(constant 2005 US) of Suriname in 1988 to that in 1989?
Make the answer very short. 0.9. What is the difference between the highest and the second highest GDP(constant 2005 US) in Fiji?
Your answer should be very brief. 2.55e+07. What is the difference between the highest and the second highest GDP(constant 2005 US) of Grenada?
Provide a short and direct response. 2.23e+07. What is the difference between the highest and the second highest GDP(constant 2005 US) in Suriname?
Your answer should be compact. 4.25e+07. What is the difference between the highest and the lowest GDP(constant 2005 US) of Fiji?
Your response must be concise. 2.27e+08. What is the difference between the highest and the lowest GDP(constant 2005 US) of Grenada?
Your answer should be compact. 1.36e+08. What is the difference between the highest and the lowest GDP(constant 2005 US) of Suriname?
Offer a very short reply. 3.39e+08. 